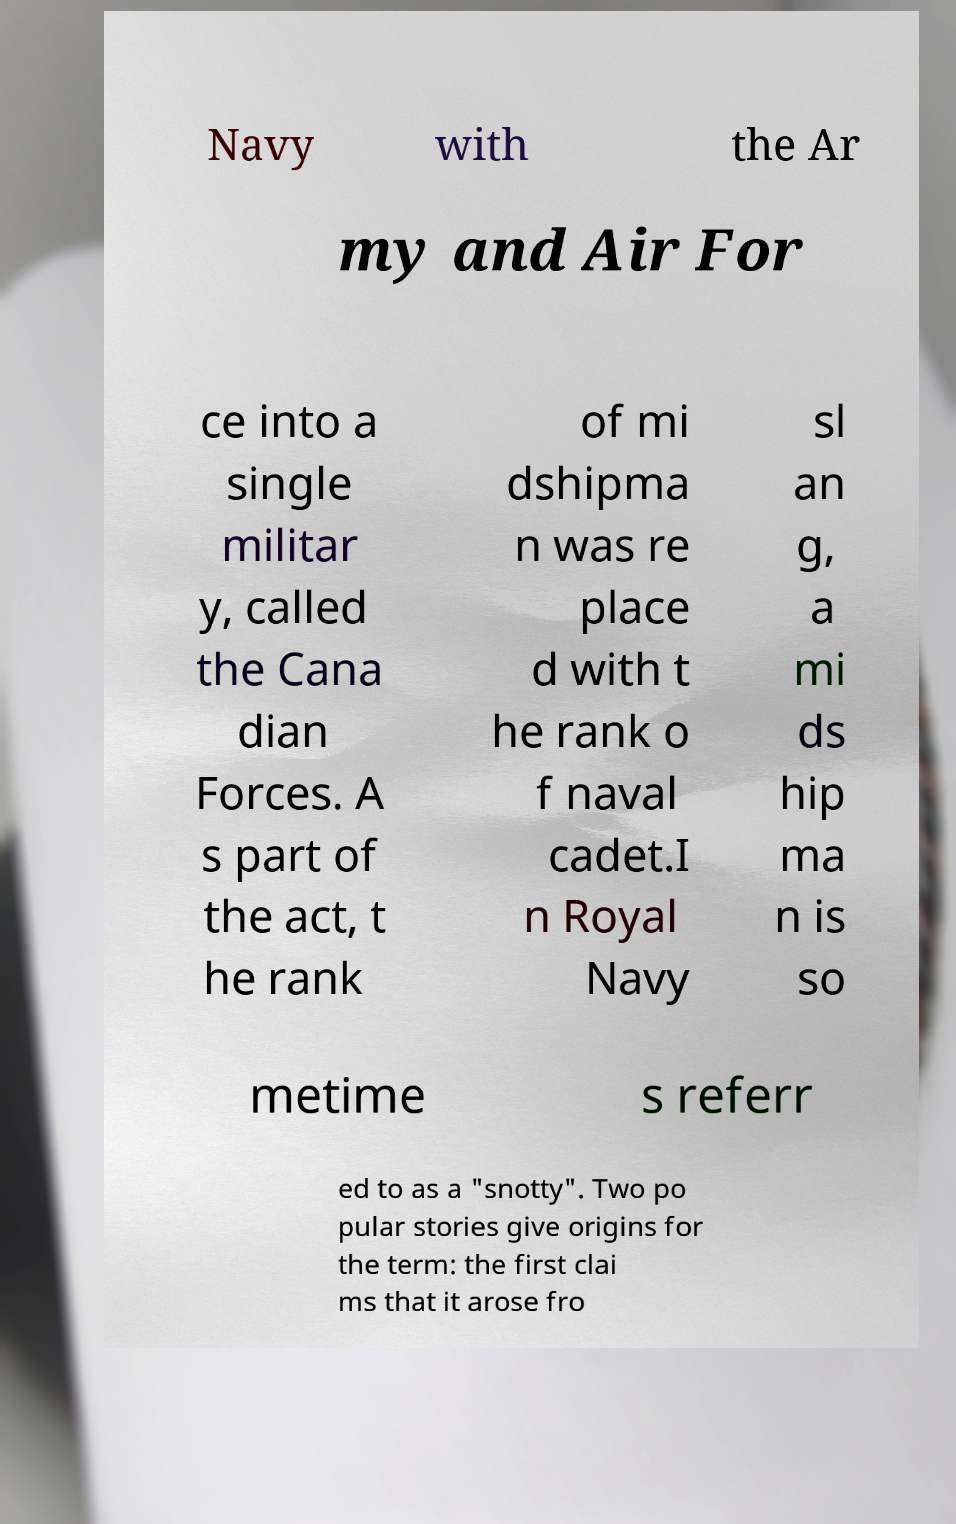Please identify and transcribe the text found in this image. Navy with the Ar my and Air For ce into a single militar y, called the Cana dian Forces. A s part of the act, t he rank of mi dshipma n was re place d with t he rank o f naval cadet.I n Royal Navy sl an g, a mi ds hip ma n is so metime s referr ed to as a "snotty". Two po pular stories give origins for the term: the first clai ms that it arose fro 